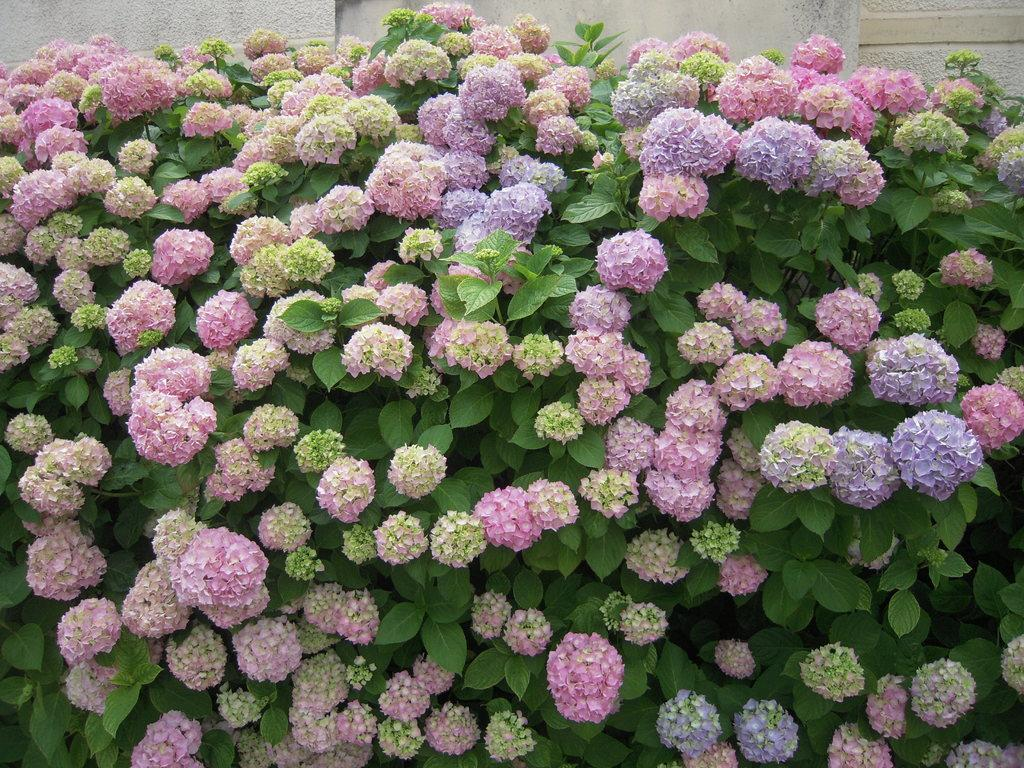Where was the image taken? The image was taken outdoors. What can be seen in the background of the image? There is a wall in the background of the image. What is the main subject of the image? The main subject of the image is plants. What is special about the plants in the image? The plants have many beautiful flowers. What color are the flowers on the plants? The flowers are pink in color. What type of account does the organization have with the bank in the image? There is no mention of an organization, bank, or account in the image; it features plants with pink flowers. 